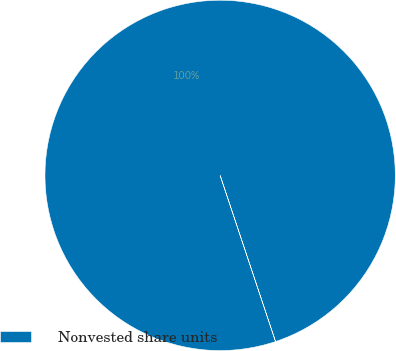Convert chart. <chart><loc_0><loc_0><loc_500><loc_500><pie_chart><fcel>Nonvested share units<nl><fcel>100.0%<nl></chart> 